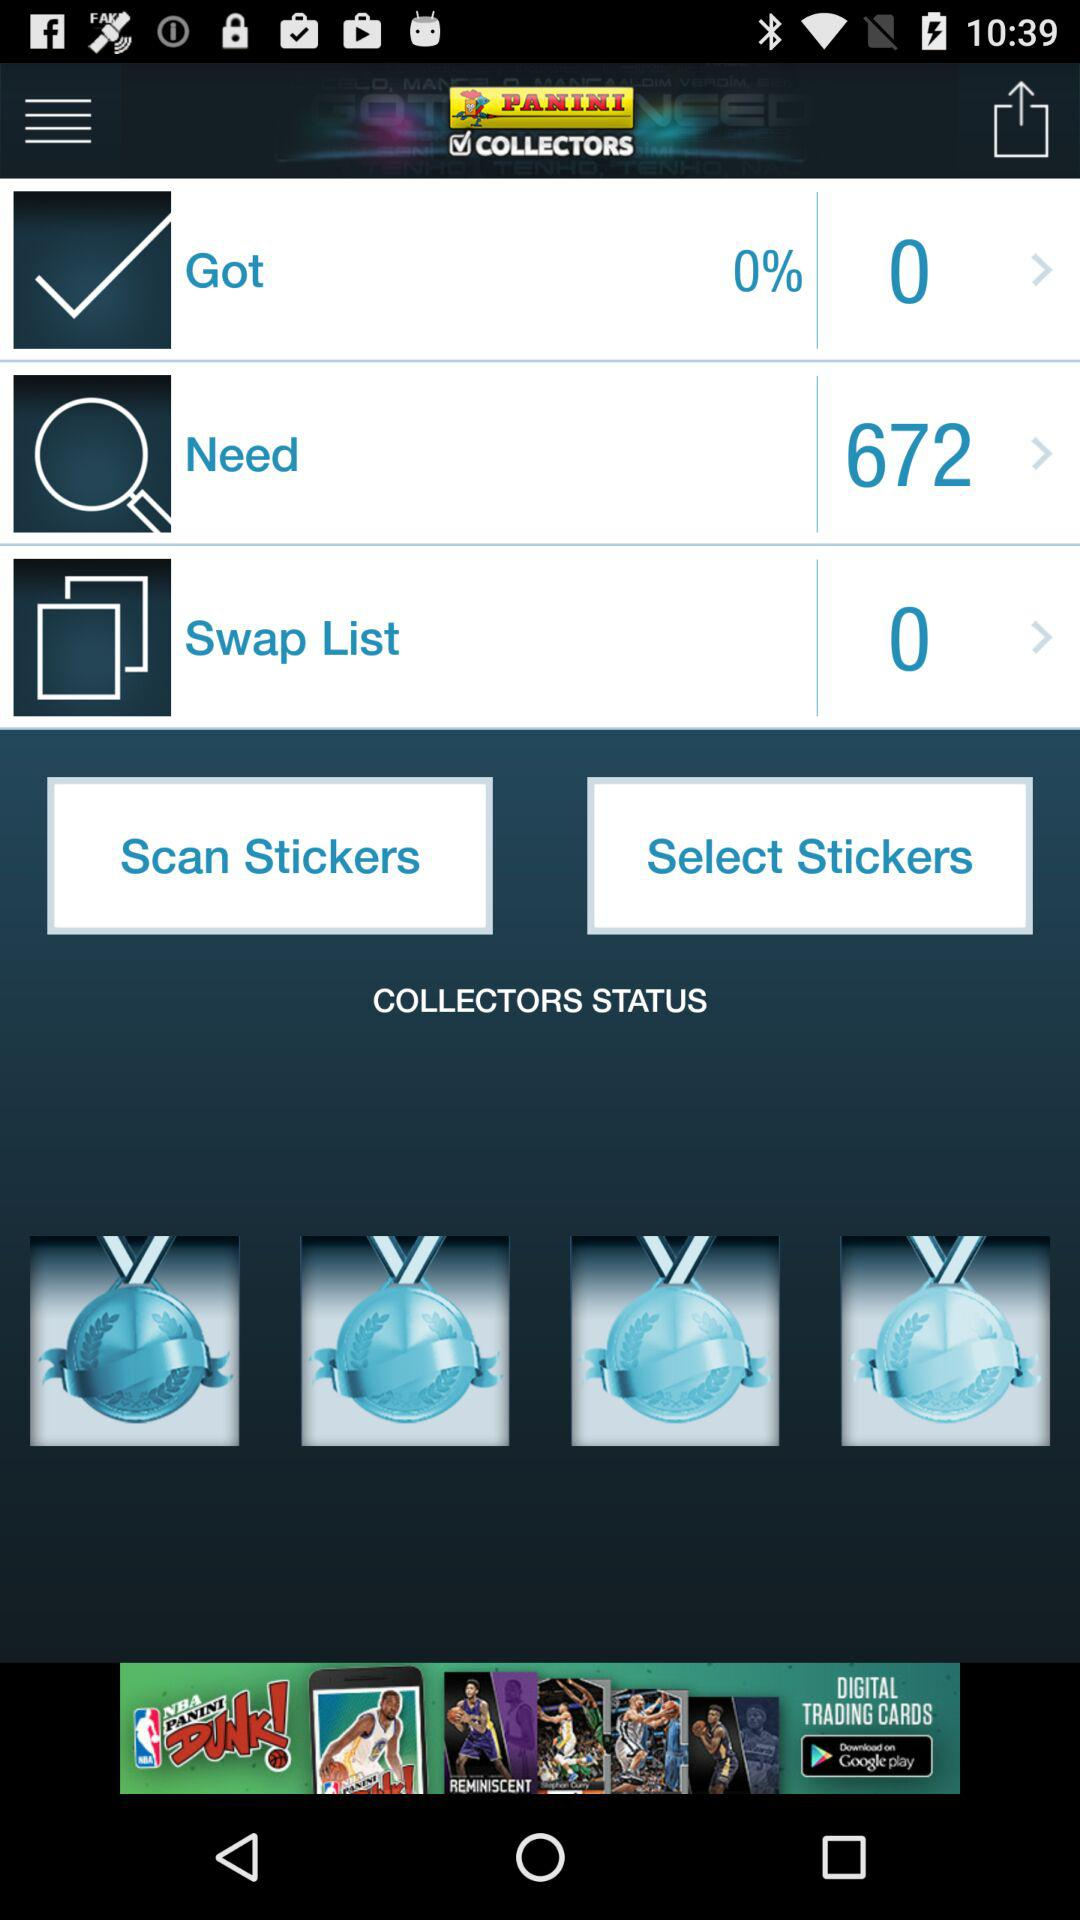What is the name of the application? The name of the application is "Panini Collectors". 